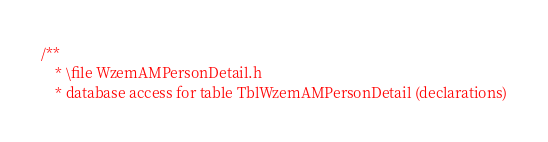Convert code to text. <code><loc_0><loc_0><loc_500><loc_500><_C_>/**
	* \file WzemAMPersonDetail.h
	* database access for table TblWzemAMPersonDetail (declarations)</code> 